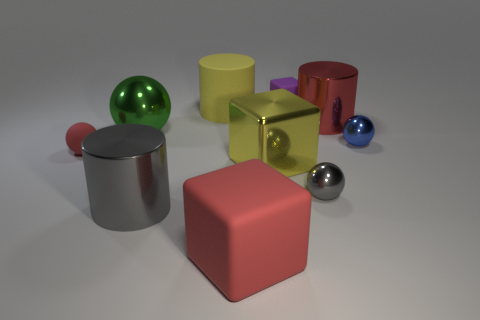What number of big things are both on the left side of the small purple rubber thing and right of the gray cylinder?
Provide a short and direct response. 3. There is a yellow thing that is in front of the red matte sphere; what material is it?
Give a very brief answer. Metal. What number of large metallic cylinders have the same color as the metal block?
Make the answer very short. 0. What is the size of the gray ball that is made of the same material as the small blue object?
Your answer should be very brief. Small. How many objects are either large red blocks or small gray spheres?
Your answer should be compact. 2. The thing that is left of the green object is what color?
Your answer should be compact. Red. What size is the blue metal object that is the same shape as the small red rubber object?
Offer a very short reply. Small. What number of things are either small gray things that are in front of the yellow metal cube or red objects that are behind the tiny blue thing?
Make the answer very short. 2. There is a metal sphere that is both on the left side of the red metallic cylinder and to the right of the purple rubber block; how big is it?
Provide a short and direct response. Small. There is a small blue thing; is it the same shape as the red thing that is in front of the big gray object?
Offer a terse response. No. 